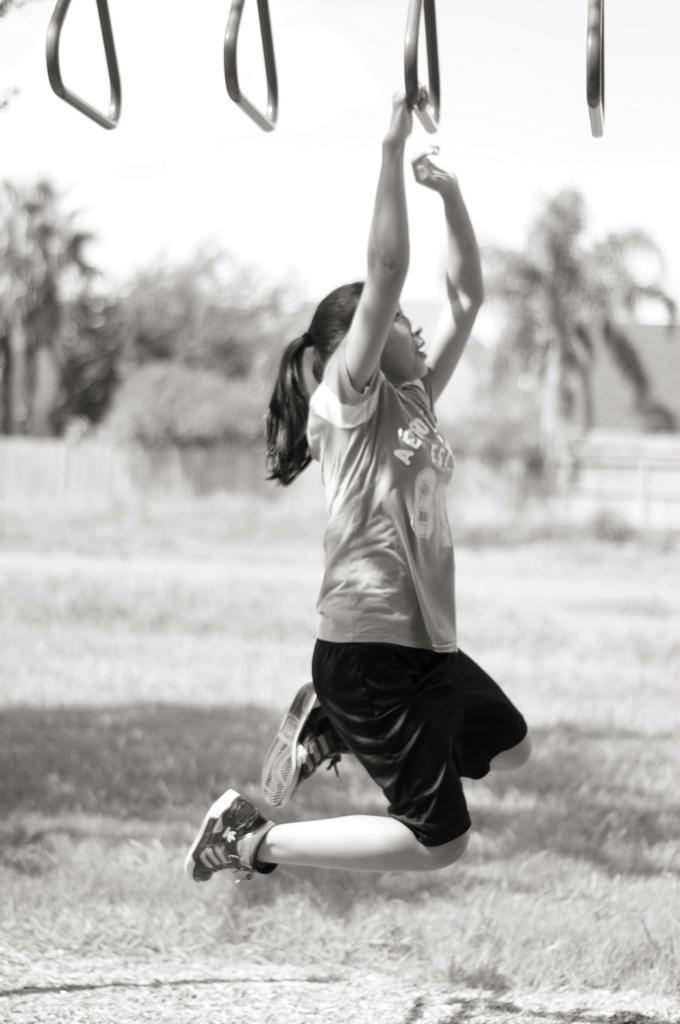Could you give a brief overview of what you see in this image? In this image there is one girl who is in air and she is doing something, and at the bottom of the image there is grass. In the background there are trees and buildings. 